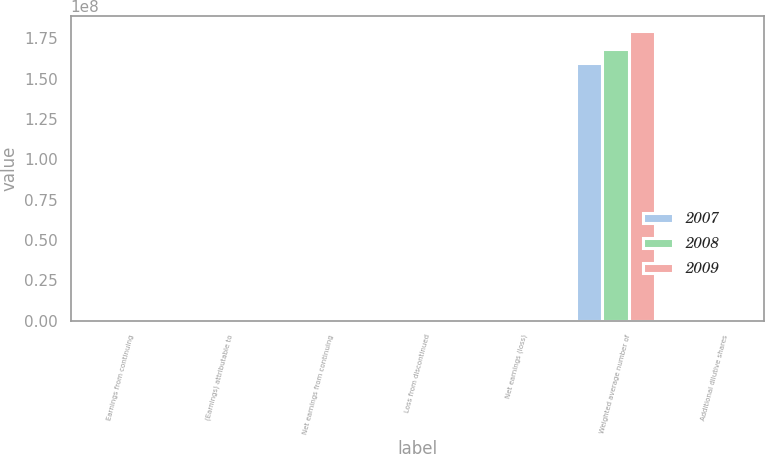Convert chart. <chart><loc_0><loc_0><loc_500><loc_500><stacked_bar_chart><ecel><fcel>Earnings from continuing<fcel>(Earnings) attributable to<fcel>Net earnings from continuing<fcel>Loss from discontinued<fcel>Net earnings (loss)<fcel>Weighted average number of<fcel>Additional dilutive shares<nl><fcel>2007<fcel>121.1<fcel>3.2<fcel>117.9<fcel>6.1<fcel>111.8<fcel>1.59965e+08<fcel>633395<nl><fcel>2008<fcel>127.5<fcel>4.6<fcel>122.9<fcel>18.5<fcel>104.4<fcel>1.68186e+08<fcel>233949<nl><fcel>2009<fcel>64.9<fcel>5.5<fcel>59.4<fcel>70.6<fcel>11.2<fcel>1.79828e+08<fcel>460436<nl></chart> 